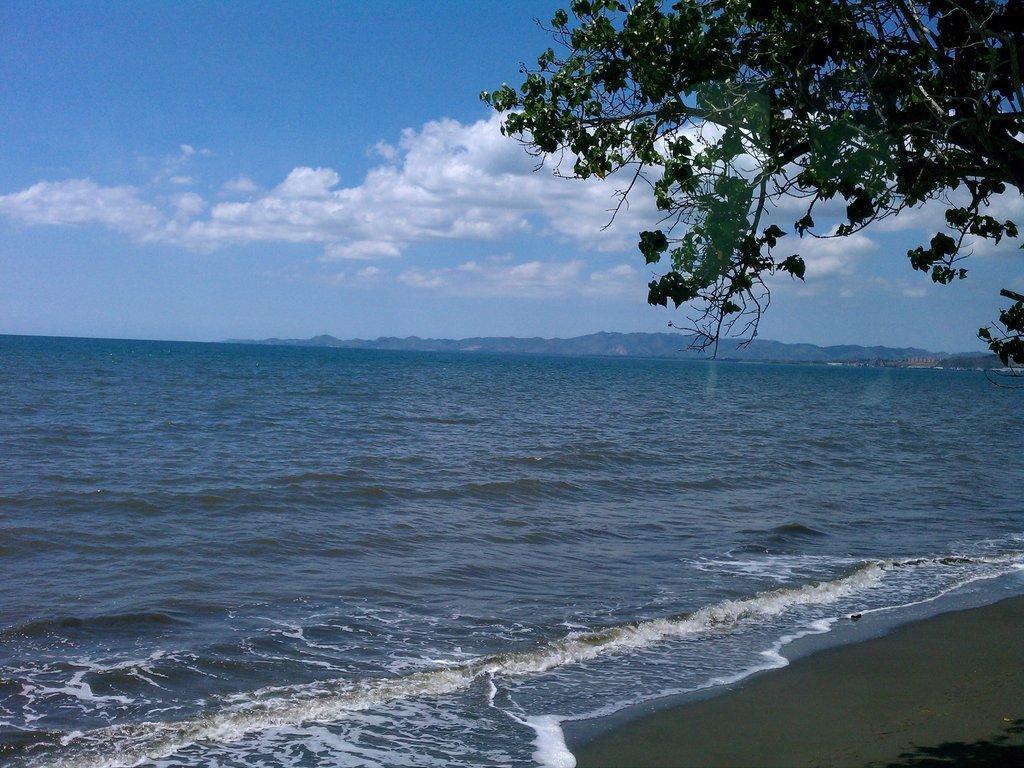In one or two sentences, can you explain what this image depicts? In the image I can see a ocean and also I can see a tree and the cloudy sky. 